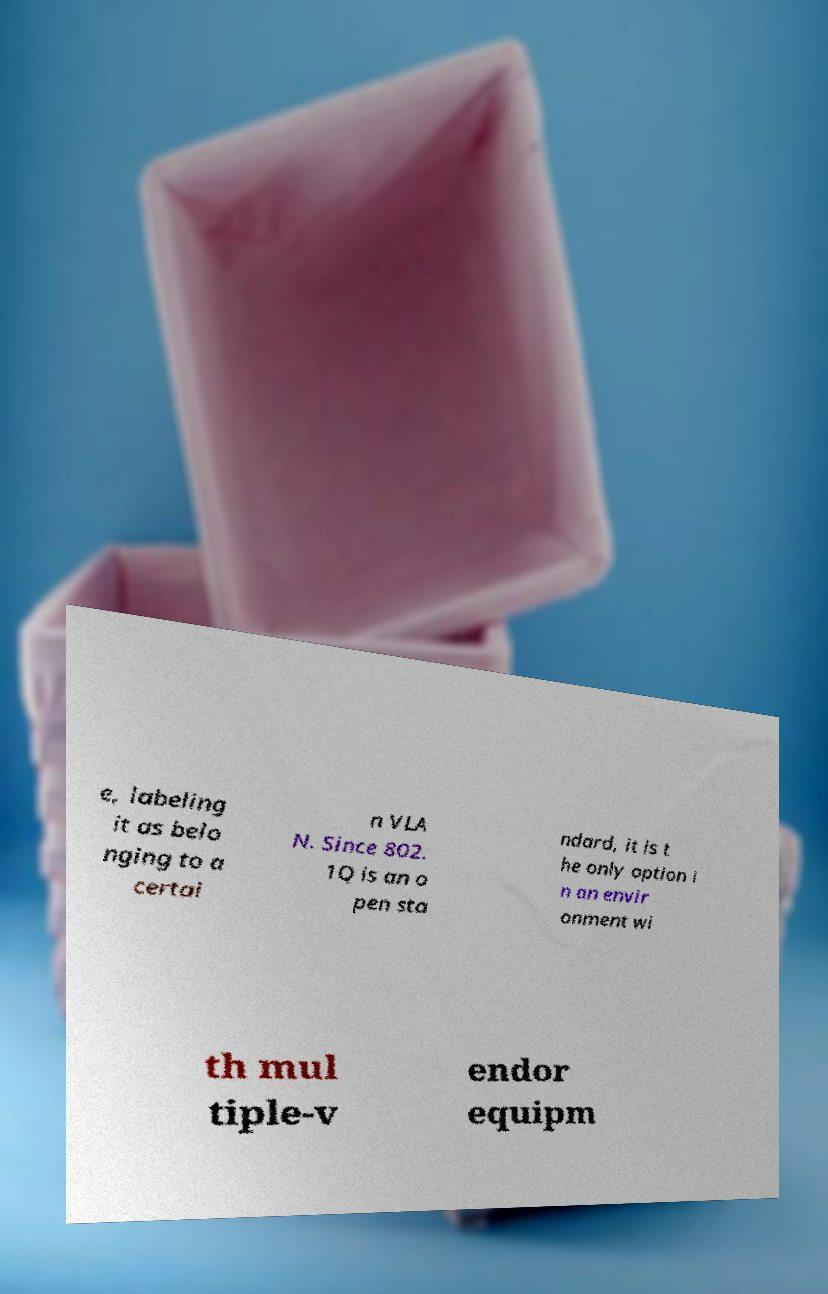Please read and relay the text visible in this image. What does it say? e, labeling it as belo nging to a certai n VLA N. Since 802. 1Q is an o pen sta ndard, it is t he only option i n an envir onment wi th mul tiple-v endor equipm 